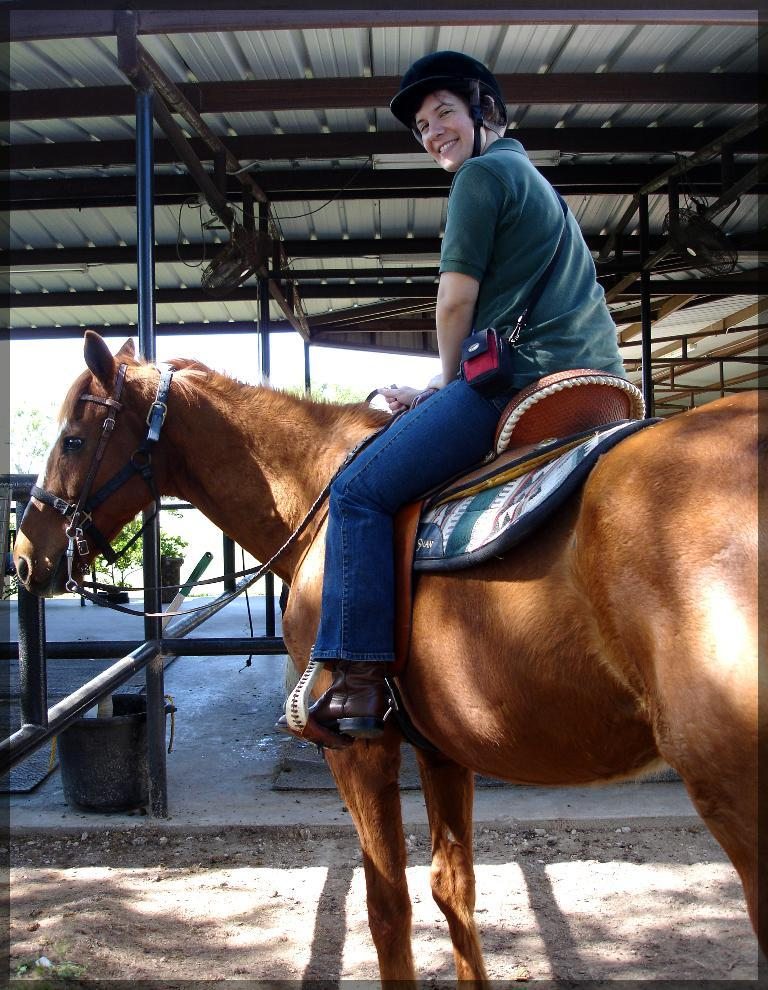What is the main subject of the image? The main subject of the image is a man. What is the man wearing? The man is wearing a green t-shirt and jeans. What is the man doing in the image? The man is sitting on a brown horse. Where is the scene taking place? The scene appears to be inside a godown. What type of establishment might the godown be? The godown seems to be an animal shelter. How much toothpaste is visible on the horse's teeth in the image? There is no toothpaste visible on the horse's teeth in the image, as the focus is on the man and his clothing. --- 